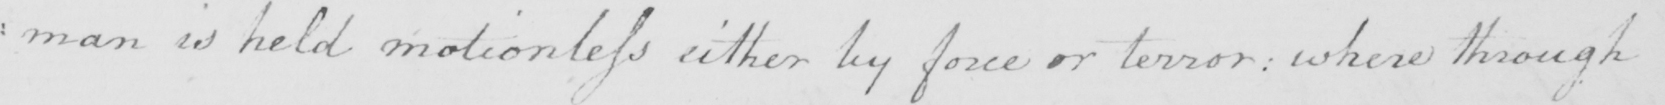What is written in this line of handwriting? : man is held motionless either by force or terror :  where through 